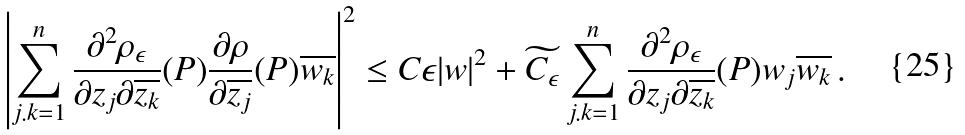Convert formula to latex. <formula><loc_0><loc_0><loc_500><loc_500>\left | \sum _ { j . k = 1 } ^ { n } \frac { \partial ^ { 2 } \rho _ { \epsilon } } { \partial z _ { j } \partial \overline { z _ { k } } } ( P ) \frac { \partial \rho } { \partial \overline { z _ { j } } } ( P ) \overline { w _ { k } } \right | ^ { 2 } \leq C \epsilon | w | ^ { 2 } + \widetilde { C _ { \epsilon } } \sum _ { j . k = 1 } ^ { n } \frac { \partial ^ { 2 } \rho _ { \epsilon } } { \partial z _ { j } \partial \overline { z _ { k } } } ( P ) w _ { j } \overline { w _ { k } } \, .</formula> 